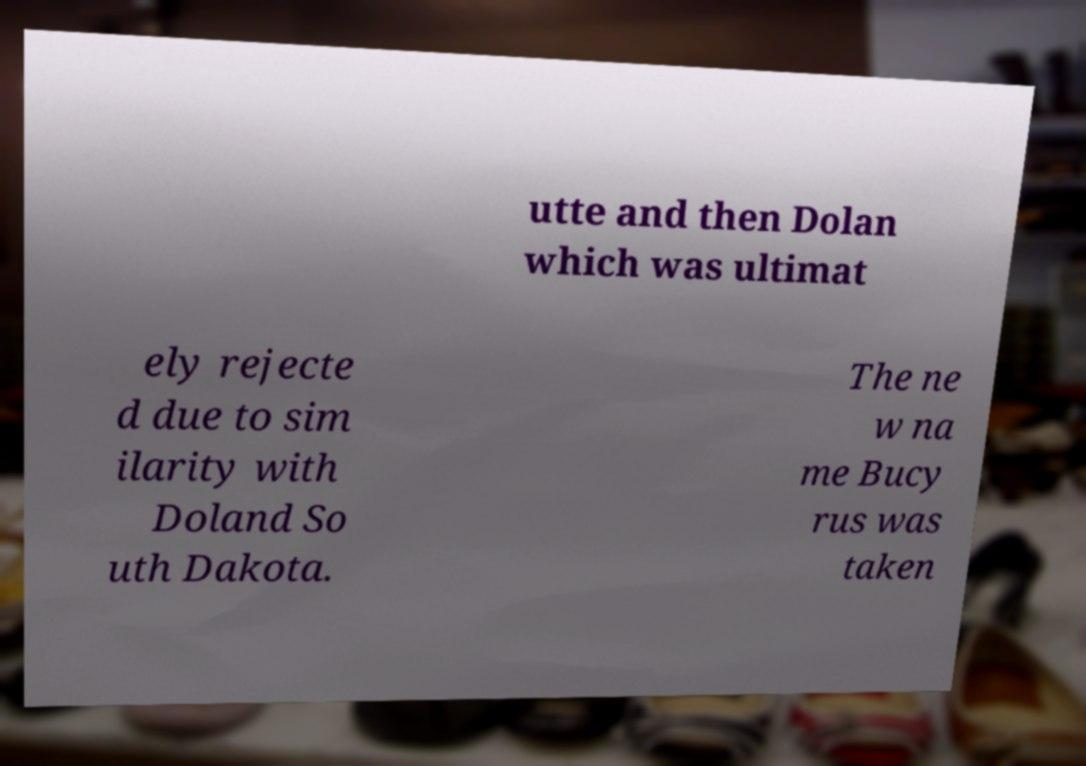For documentation purposes, I need the text within this image transcribed. Could you provide that? utte and then Dolan which was ultimat ely rejecte d due to sim ilarity with Doland So uth Dakota. The ne w na me Bucy rus was taken 